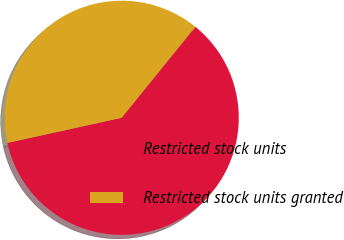<chart> <loc_0><loc_0><loc_500><loc_500><pie_chart><fcel>Restricted stock units<fcel>Restricted stock units granted<nl><fcel>60.72%<fcel>39.28%<nl></chart> 